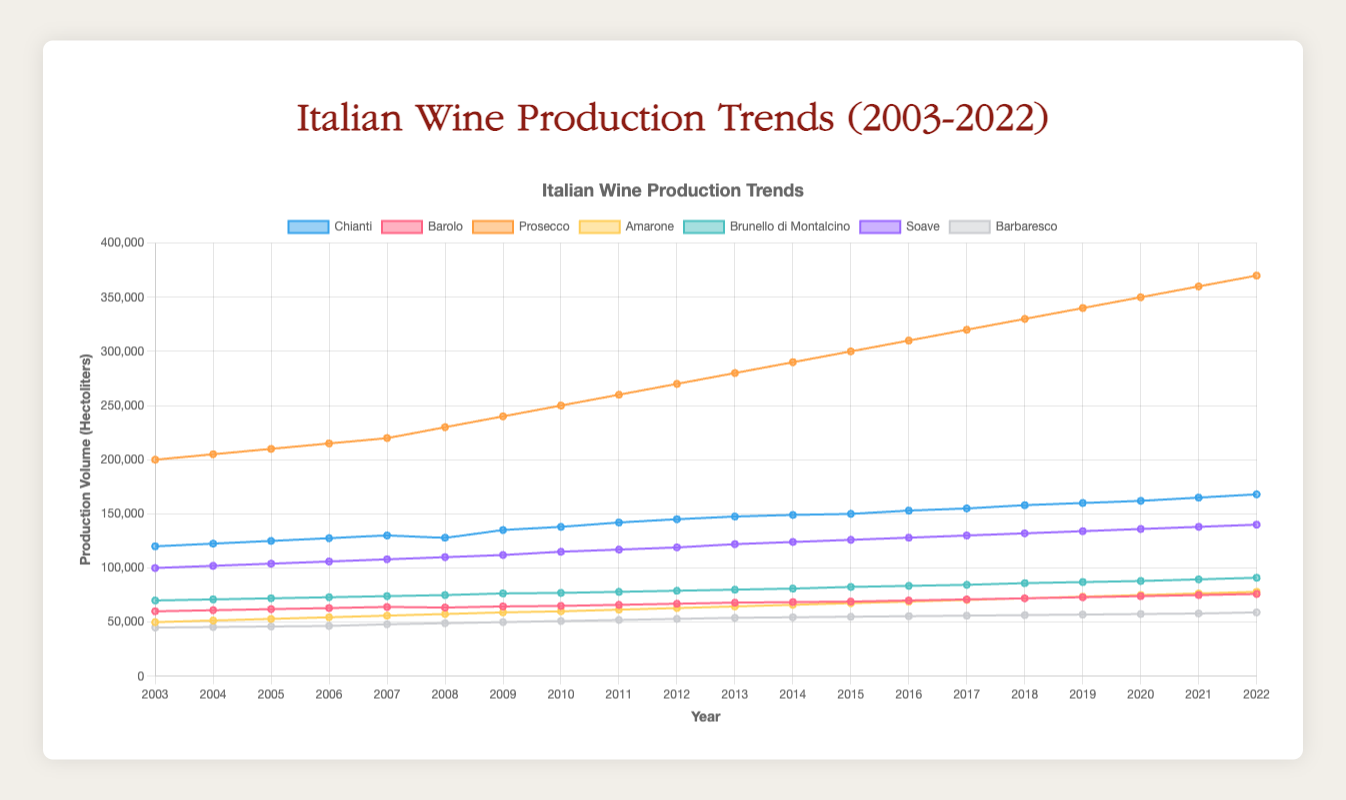What is the overall trend in the production of Chianti wine from 2003 to 2022? The overall trend shows a continual increase in Chianti production from 120,000 hectoliters in 2003 to 168,000 hectoliters in 2022.
Answer: Increasing Which wine had the highest production volume in 2010? By comparing the production volumes of all wines in 2010, Prosecco had the highest production volume at 250,000 hectoliters.
Answer: Prosecco Between 2012 and 2016, how much did the production volume of Amarone increase? The production volume of Amarone increased from 63,000 hectoliters in 2012 to 69,000 hectoliters in 2016, resulting in an increase of 69,000 - 63,000 = 6,000 hectoliters.
Answer: 6,000 hectoliters Which wine showed the most significant growth in production volume between 2008 and 2022? By comparing the difference in production volumes for all wines between 2008 and 2022, Prosecco had the most significant growth, increasing from 230,000 to 370,000 hectoliters. This results in an increase of 370,000 - 230,000 = 140,000 hectoliters.
Answer: Prosecco How does the production volume of Soave in 2015 compare to that in 2020? The production volume of Soave in 2015 was 126,000 hectoliters, while in 2020 it was 136,000 hectoliters. Thus, Soave's production volume increased by 136,000 - 126,000 = 10,000 hectoliters from 2015 to 2020.
Answer: Soave in 2020 was higher by 10,000 hectoliters What is the production volume difference between Chianti and Barbaresco in 2022? In 2022, Chianti had a production volume of 168,000 hectoliters, and Barbaresco had 59,000 hectoliters. The difference is 168,000 - 59,000 = 109,000 hectoliters.
Answer: 109,000 hectoliters Which wine had the smallest increase in production volume between 2003 and 2022? By calculating the difference in production volumes for all wines between 2003 and 2022, Barbaresco showed the smallest increase, from 45,000 to 59,000 hectoliters, resulting in an increase of 14,000 hectoliters.
Answer: Barbaresco What is the average production volume of Prosecco over the past 20 years (2003-2022)? The total production volume of Prosecco over 20 years is 200,000 + 205,000 + 210,000 + 215,000 + 220,000 + 230,000 + 240,000 + 250,000 + 260,000 + 270,000 + 280,000 + 290,000 + 300,000 + 310,000 + 320,000 + 330,000 + 340,000 + 350,000 + 360,000 + 370,000 = 4,509,000 hectoliters. The average production volume is 4,509,000 / 20 = 225,450 hectoliters.
Answer: 225,450 hectoliters Which wine showed little variation in production volumes over the observed period? By observing the stability of production volumes over the years, it's evident that Barolo showed relatively little variation, increasing steadily without significant spikes or drops, from 60,000 hectoliters in 2003 to 76,000 hectoliters in 2022.
Answer: Barolo Between 2009 and 2019, how many times did Brunello di Montalcino's production volume exceed 80,000 hectoliters? Comparing the data, Brunello di Montalcino's production volume exceeded 80,000 hectoliters from 2013 to 2019 (7 occurrences).
Answer: 7 times 